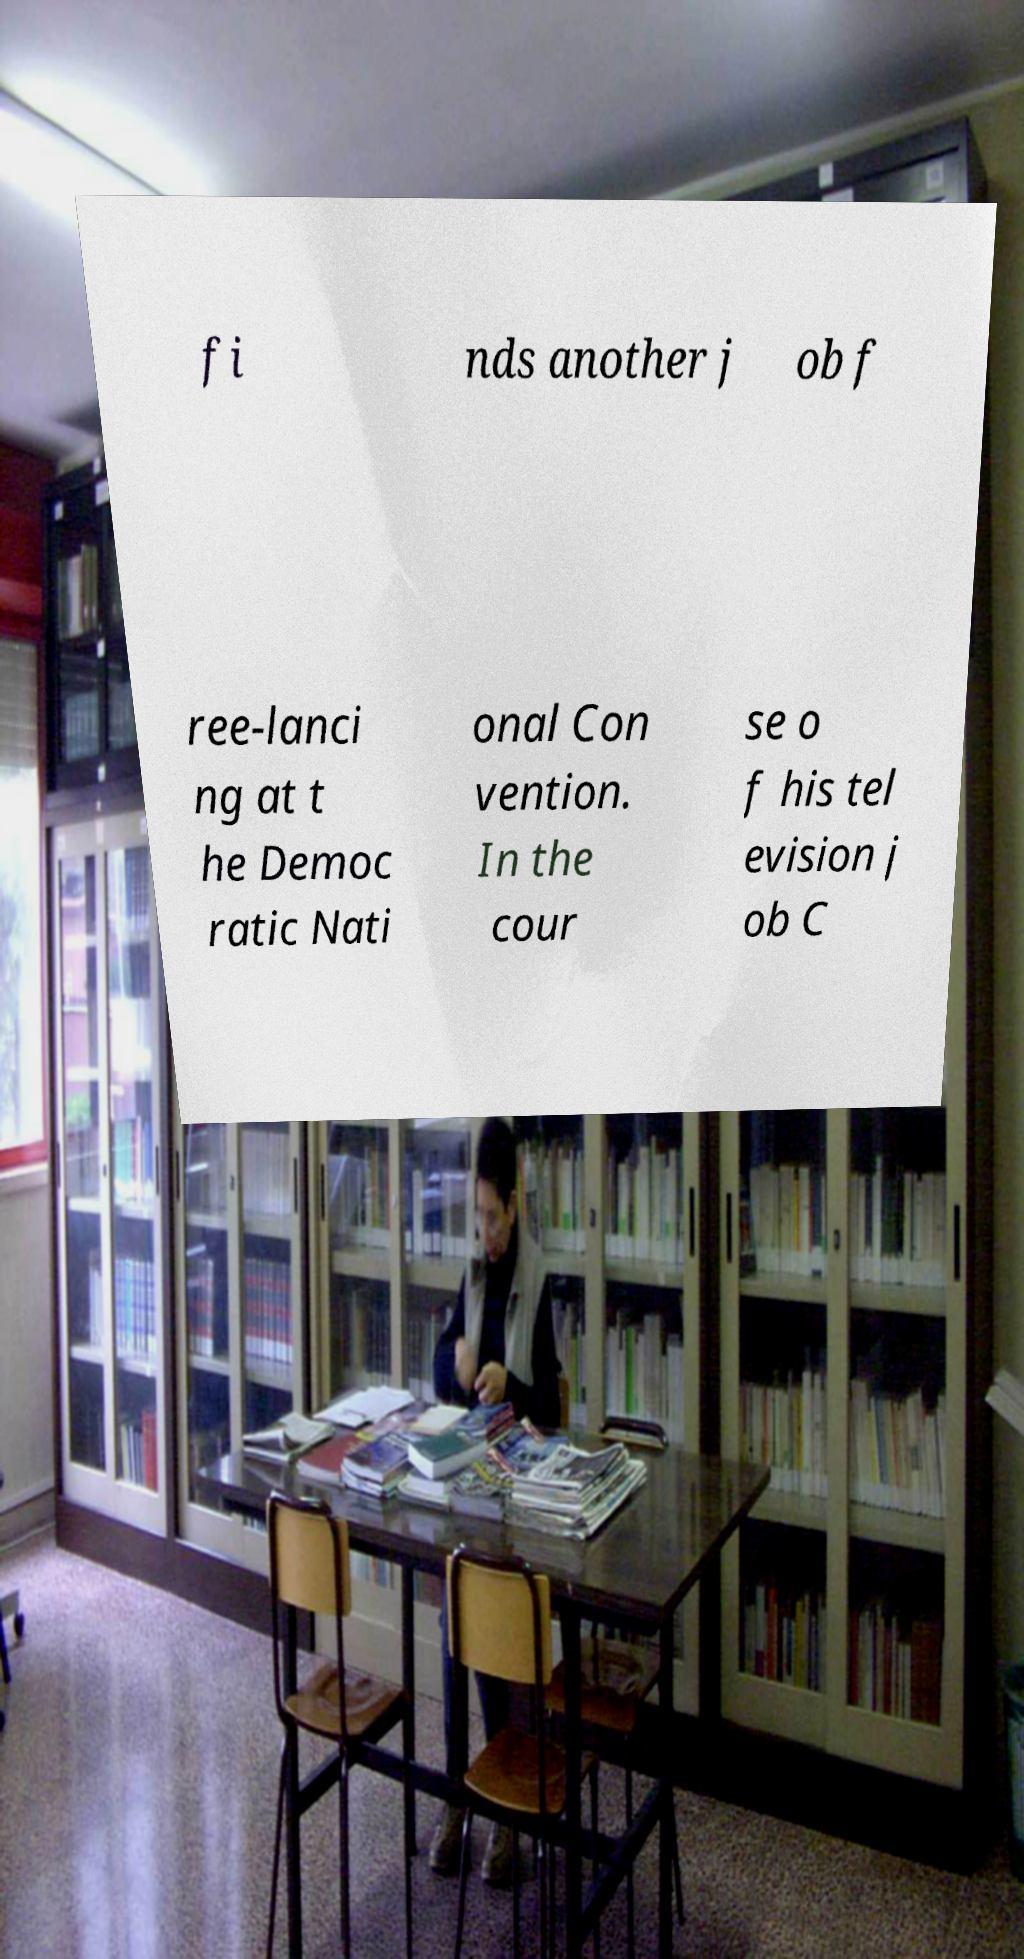Can you read and provide the text displayed in the image?This photo seems to have some interesting text. Can you extract and type it out for me? fi nds another j ob f ree-lanci ng at t he Democ ratic Nati onal Con vention. In the cour se o f his tel evision j ob C 